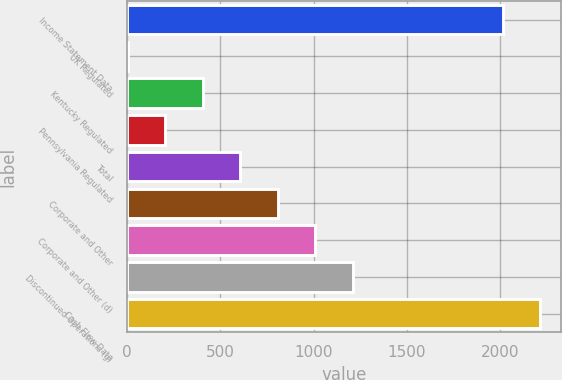Convert chart to OTSL. <chart><loc_0><loc_0><loc_500><loc_500><bar_chart><fcel>Income Statement Data<fcel>UK Regulated<fcel>Kentucky Regulated<fcel>Pennsylvania Regulated<fcel>Total<fcel>Corporate and Other<fcel>Corporate and Other (d)<fcel>Discontinued Operations (g)<fcel>Cash Flow Data<nl><fcel>2015<fcel>6<fcel>407.8<fcel>206.9<fcel>608.7<fcel>809.6<fcel>1010.5<fcel>1211.4<fcel>2215.9<nl></chart> 